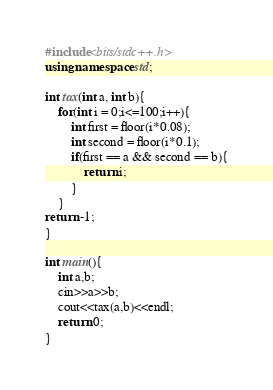<code> <loc_0><loc_0><loc_500><loc_500><_C++_>#include<bits/stdc++.h>
using namespace std;

int tax(int a, int b){
	for(int i = 0;i<=100;i++){
		int first = floor(i*0.08);
		int second = floor(i*0.1);
		if(first == a && second == b){
			return i;
		}
	}
return -1;
}

int main(){
	int a,b;
	cin>>a>>b;
	cout<<tax(a,b)<<endl;
	return 0;
}
</code> 